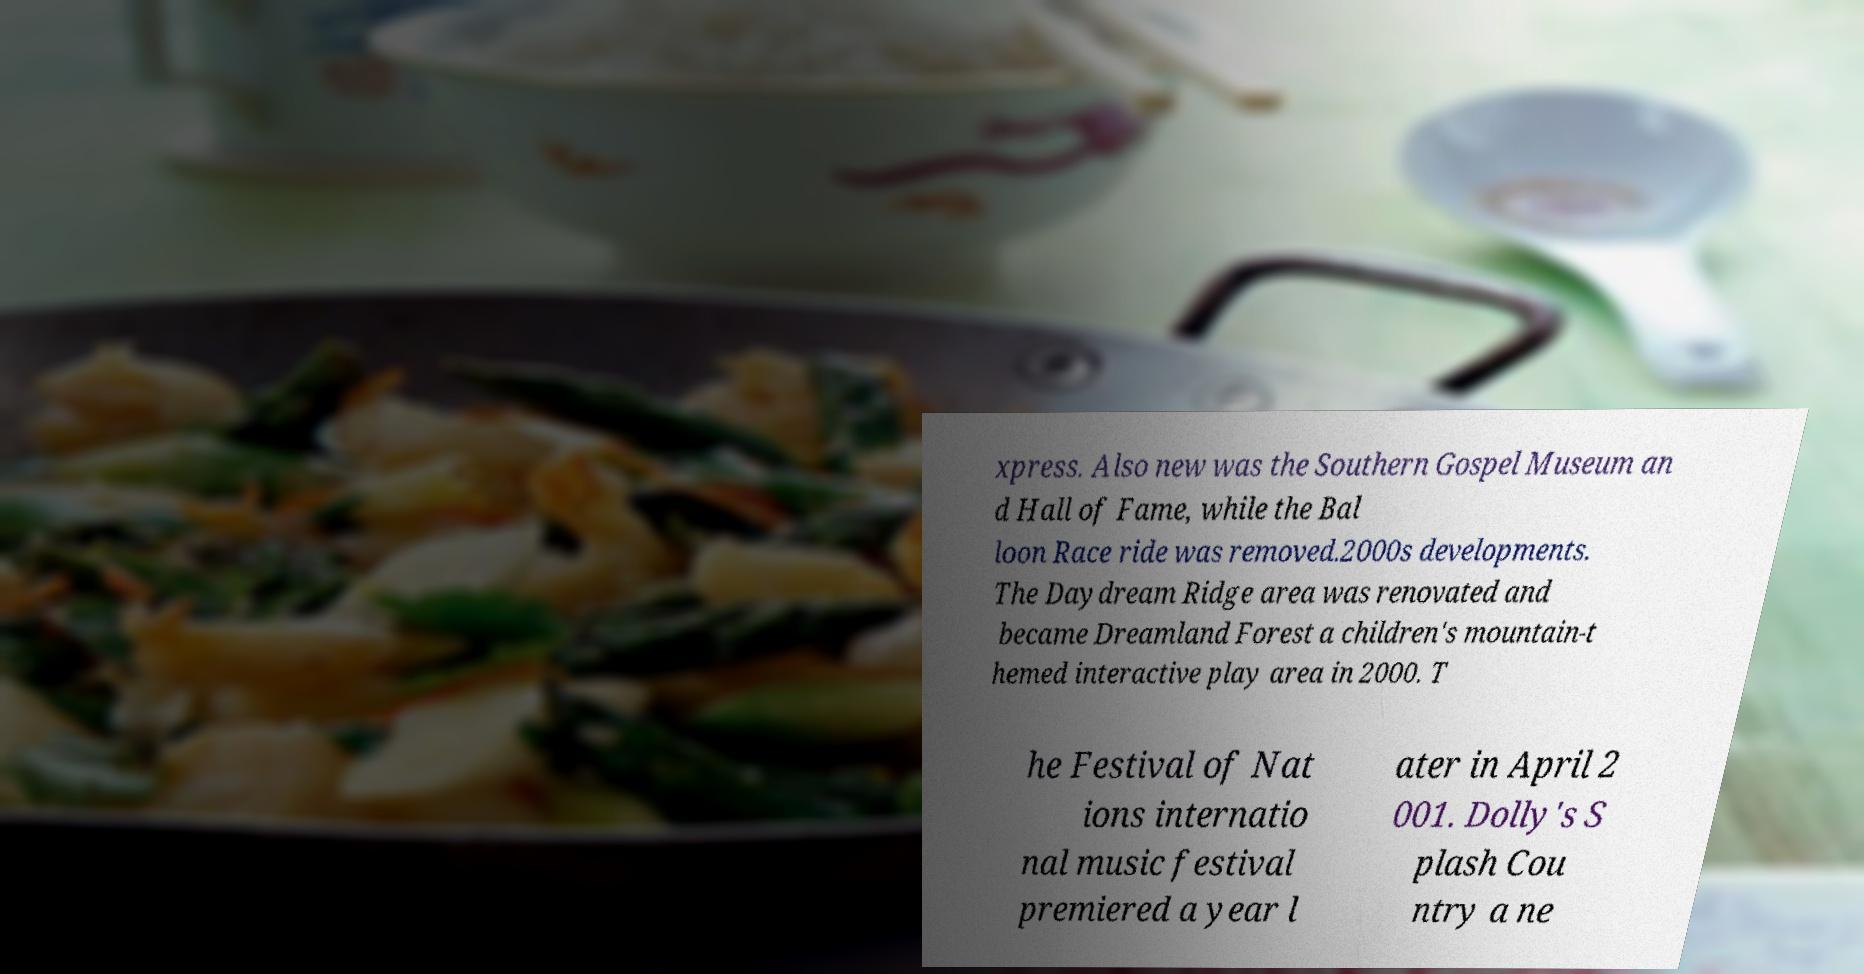What messages or text are displayed in this image? I need them in a readable, typed format. xpress. Also new was the Southern Gospel Museum an d Hall of Fame, while the Bal loon Race ride was removed.2000s developments. The Daydream Ridge area was renovated and became Dreamland Forest a children's mountain-t hemed interactive play area in 2000. T he Festival of Nat ions internatio nal music festival premiered a year l ater in April 2 001. Dolly's S plash Cou ntry a ne 